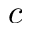Convert formula to latex. <formula><loc_0><loc_0><loc_500><loc_500>c</formula> 